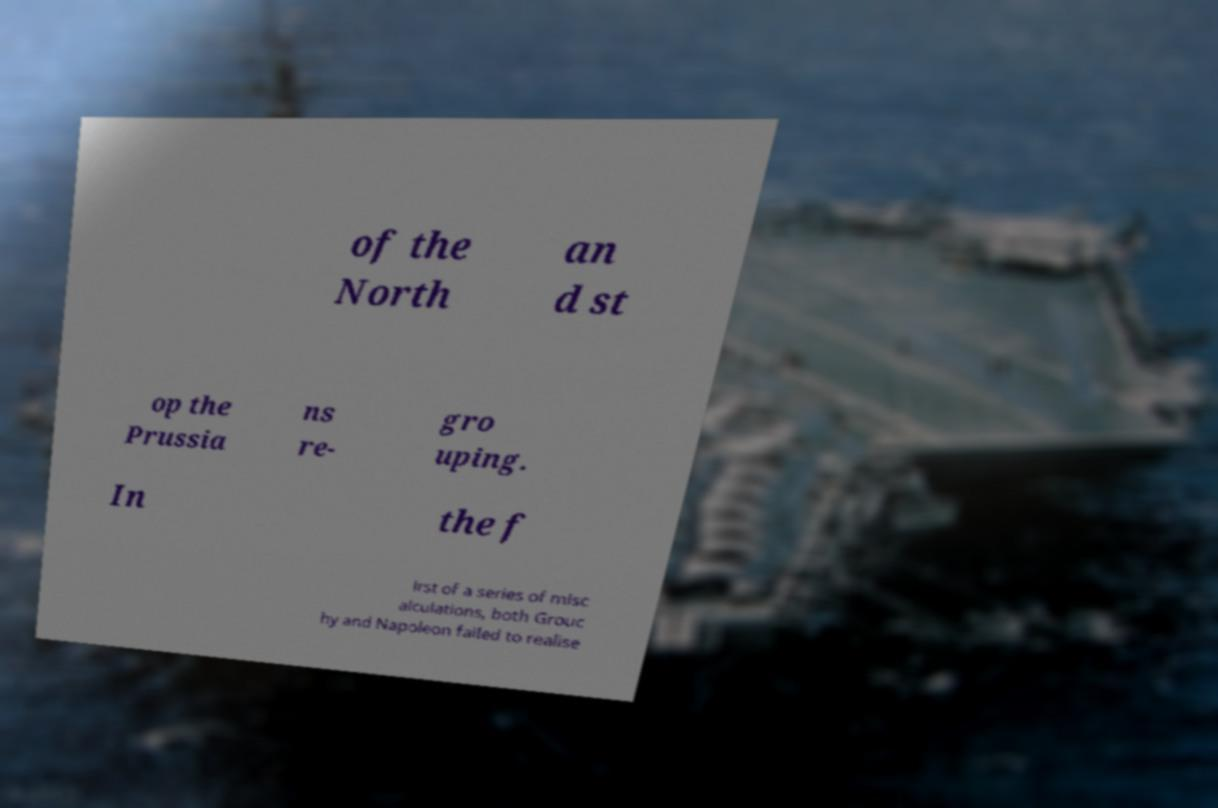Can you read and provide the text displayed in the image?This photo seems to have some interesting text. Can you extract and type it out for me? of the North an d st op the Prussia ns re- gro uping. In the f irst of a series of misc alculations, both Grouc hy and Napoleon failed to realise 